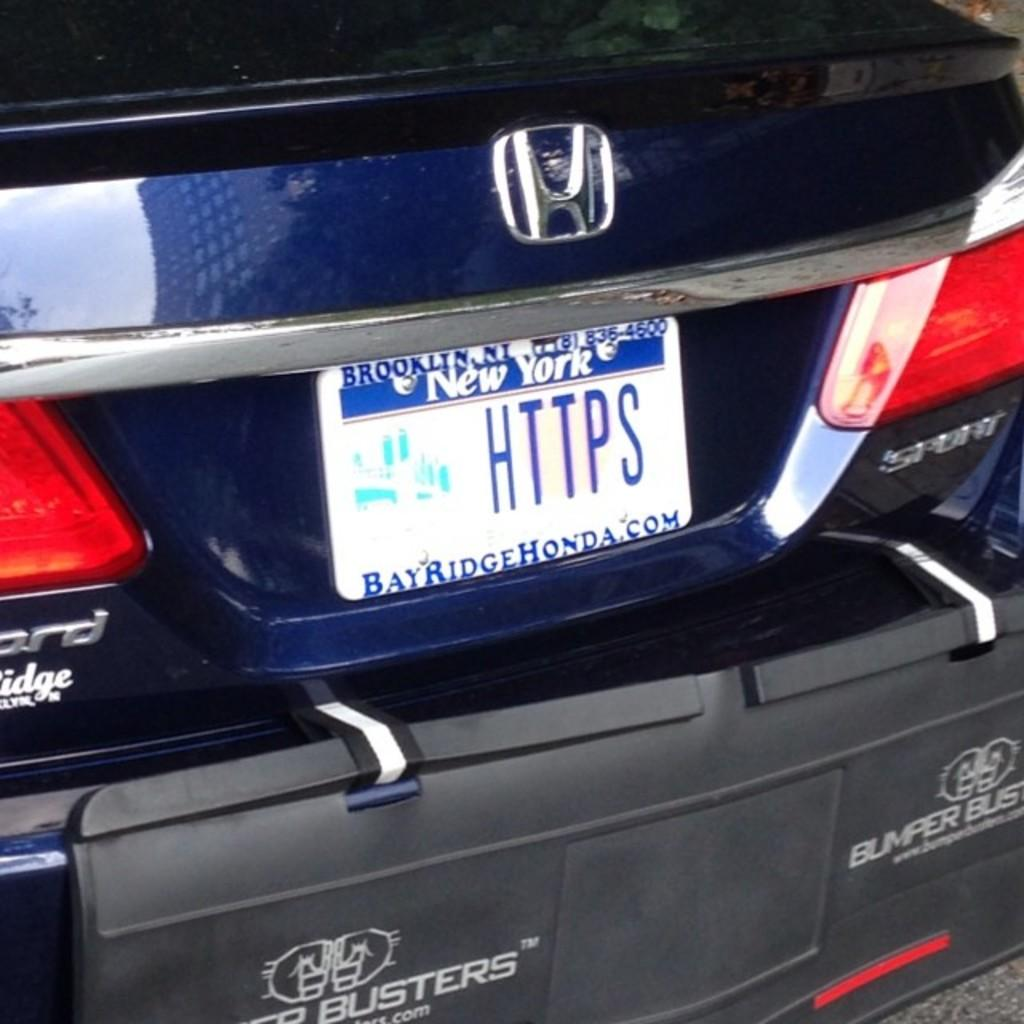Provide a one-sentence caption for the provided image. A license plate on a car shows the letters HTTPS. 